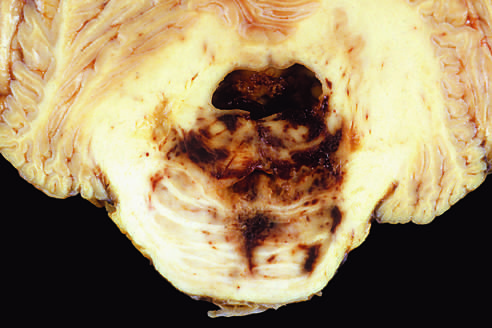what displaces the brain downward?
Answer the question using a single word or phrase. Mass effect 